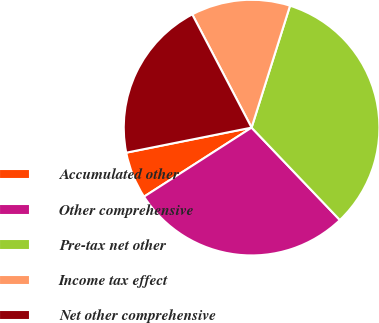<chart> <loc_0><loc_0><loc_500><loc_500><pie_chart><fcel>Accumulated other<fcel>Other comprehensive<fcel>Pre-tax net other<fcel>Income tax effect<fcel>Net other comprehensive<nl><fcel>5.94%<fcel>28.05%<fcel>33.0%<fcel>12.54%<fcel>20.46%<nl></chart> 